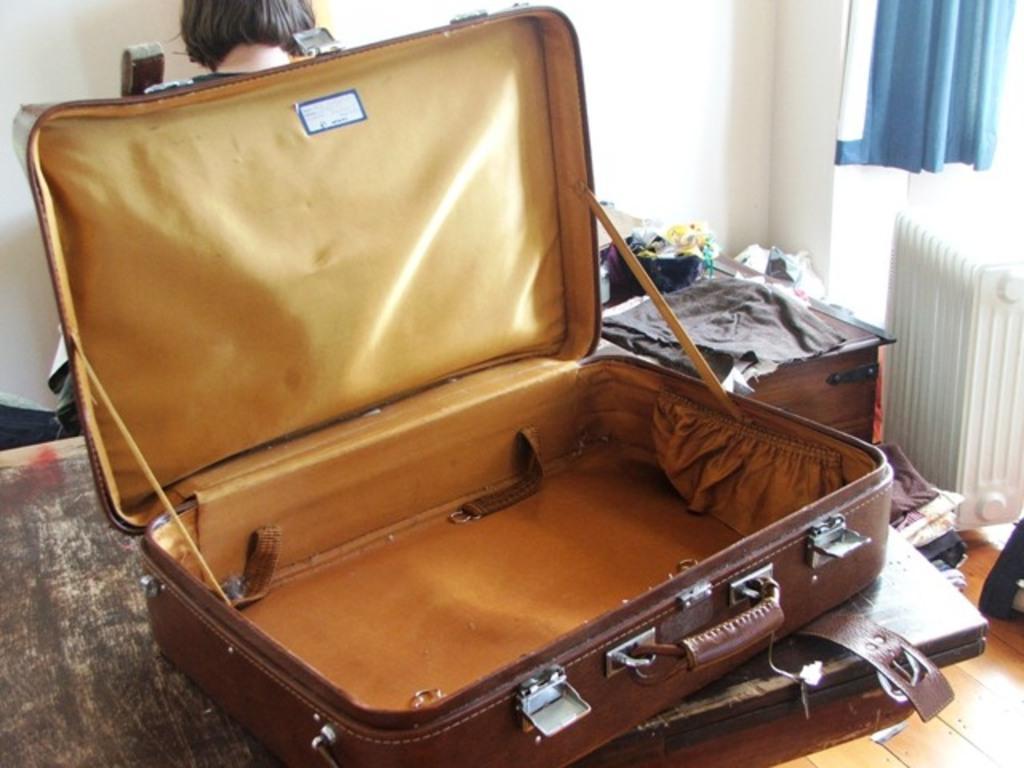Please provide a concise description of this image. This is bag,back side there is woman,this are clothes,there is blue color curtain. 